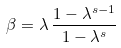Convert formula to latex. <formula><loc_0><loc_0><loc_500><loc_500>\beta = \lambda \, \frac { 1 - \lambda ^ { s - 1 } } { 1 - \lambda ^ { s } }</formula> 